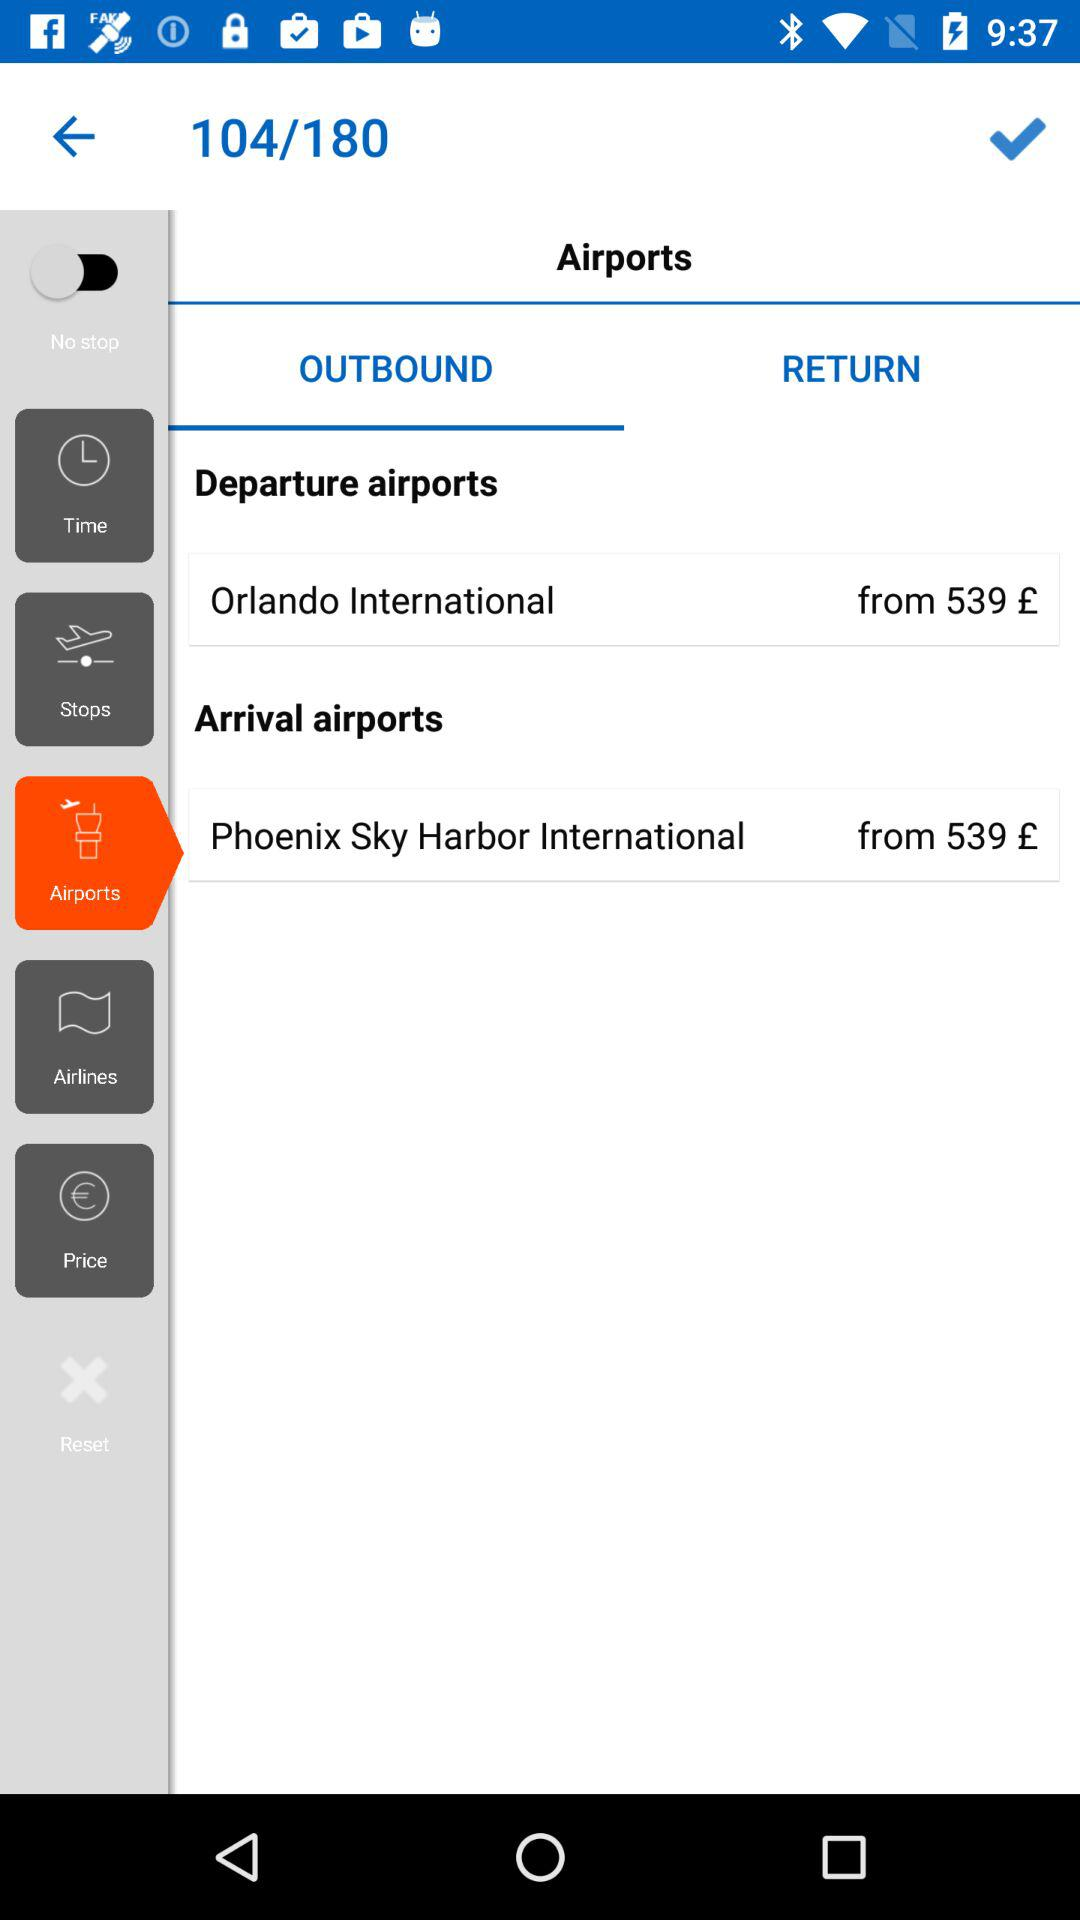What is the starting price of a departure ticket from "Orlando International"? The starting price of a departure ticket from "Orlando International" is £539. 